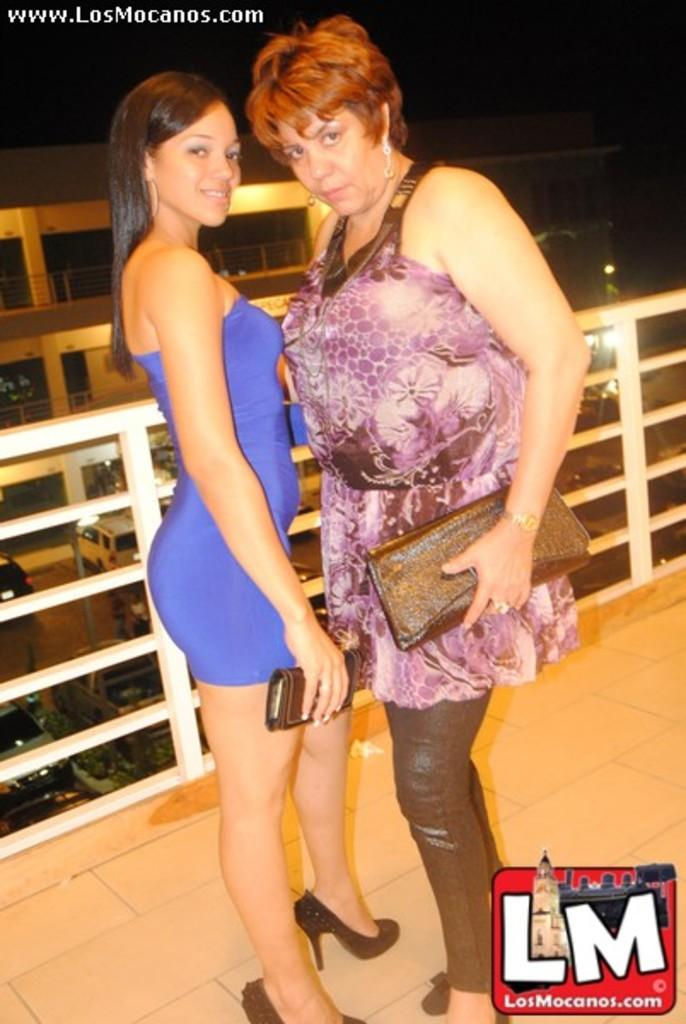How many women are present in the image? There are two women standing in the image. What is the surface on which the women are standing? The women are standing on the floor. What can be seen in the background of the image? There are vehicles, lights, and a building in the background of the image. Are there any cherries visible on the women's clothing in the image? There are no cherries visible on the women's clothing in the image. Can you tell if the women are sleeping in the image? The women are standing in the image, so they are not sleeping. 